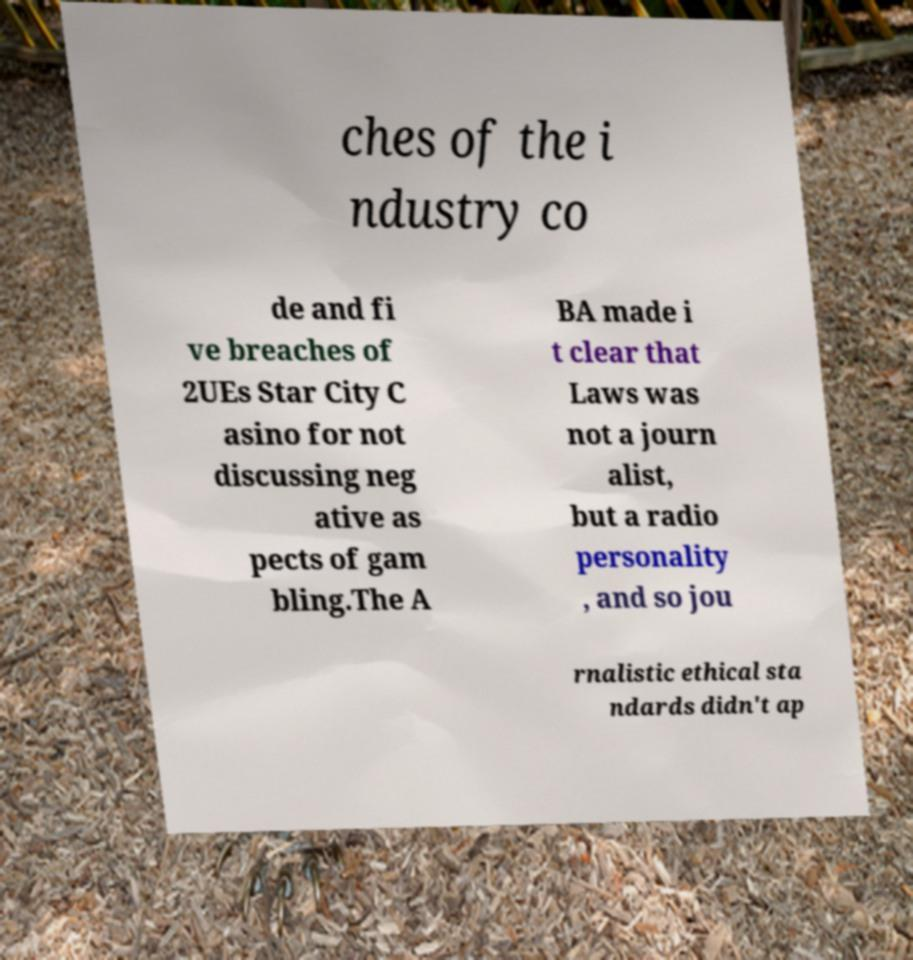Can you read and provide the text displayed in the image?This photo seems to have some interesting text. Can you extract and type it out for me? ches of the i ndustry co de and fi ve breaches of 2UEs Star City C asino for not discussing neg ative as pects of gam bling.The A BA made i t clear that Laws was not a journ alist, but a radio personality , and so jou rnalistic ethical sta ndards didn't ap 